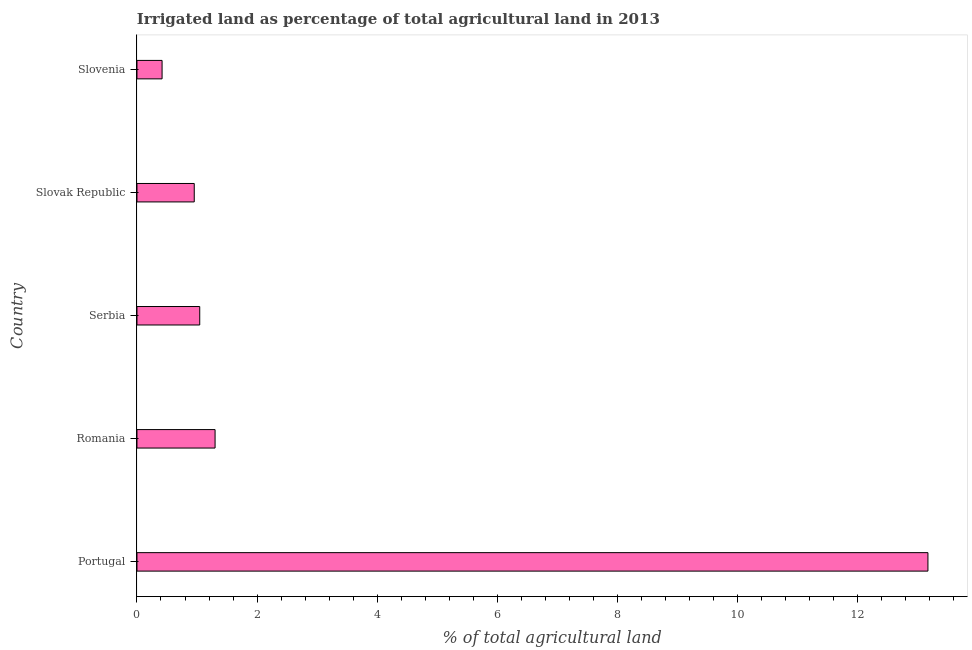Does the graph contain any zero values?
Offer a terse response. No. What is the title of the graph?
Make the answer very short. Irrigated land as percentage of total agricultural land in 2013. What is the label or title of the X-axis?
Ensure brevity in your answer.  % of total agricultural land. What is the percentage of agricultural irrigated land in Portugal?
Give a very brief answer. 13.17. Across all countries, what is the maximum percentage of agricultural irrigated land?
Keep it short and to the point. 13.17. Across all countries, what is the minimum percentage of agricultural irrigated land?
Provide a succinct answer. 0.42. In which country was the percentage of agricultural irrigated land minimum?
Your answer should be very brief. Slovenia. What is the sum of the percentage of agricultural irrigated land?
Provide a succinct answer. 16.89. What is the difference between the percentage of agricultural irrigated land in Serbia and Slovak Republic?
Provide a succinct answer. 0.09. What is the average percentage of agricultural irrigated land per country?
Your response must be concise. 3.38. What is the median percentage of agricultural irrigated land?
Provide a short and direct response. 1.05. In how many countries, is the percentage of agricultural irrigated land greater than 2.8 %?
Give a very brief answer. 1. What is the ratio of the percentage of agricultural irrigated land in Slovak Republic to that in Slovenia?
Your answer should be compact. 2.28. What is the difference between the highest and the second highest percentage of agricultural irrigated land?
Ensure brevity in your answer.  11.87. What is the difference between the highest and the lowest percentage of agricultural irrigated land?
Your response must be concise. 12.76. In how many countries, is the percentage of agricultural irrigated land greater than the average percentage of agricultural irrigated land taken over all countries?
Ensure brevity in your answer.  1. How many bars are there?
Make the answer very short. 5. Are all the bars in the graph horizontal?
Give a very brief answer. Yes. How many countries are there in the graph?
Your answer should be compact. 5. Are the values on the major ticks of X-axis written in scientific E-notation?
Offer a terse response. No. What is the % of total agricultural land in Portugal?
Your answer should be compact. 13.17. What is the % of total agricultural land of Romania?
Your answer should be very brief. 1.3. What is the % of total agricultural land in Serbia?
Your answer should be very brief. 1.05. What is the % of total agricultural land of Slovak Republic?
Make the answer very short. 0.95. What is the % of total agricultural land in Slovenia?
Ensure brevity in your answer.  0.42. What is the difference between the % of total agricultural land in Portugal and Romania?
Provide a short and direct response. 11.87. What is the difference between the % of total agricultural land in Portugal and Serbia?
Offer a very short reply. 12.13. What is the difference between the % of total agricultural land in Portugal and Slovak Republic?
Provide a short and direct response. 12.22. What is the difference between the % of total agricultural land in Portugal and Slovenia?
Offer a terse response. 12.76. What is the difference between the % of total agricultural land in Romania and Serbia?
Offer a terse response. 0.26. What is the difference between the % of total agricultural land in Romania and Slovak Republic?
Your answer should be compact. 0.35. What is the difference between the % of total agricultural land in Romania and Slovenia?
Provide a succinct answer. 0.88. What is the difference between the % of total agricultural land in Serbia and Slovak Republic?
Your answer should be compact. 0.09. What is the difference between the % of total agricultural land in Serbia and Slovenia?
Provide a short and direct response. 0.63. What is the difference between the % of total agricultural land in Slovak Republic and Slovenia?
Provide a succinct answer. 0.54. What is the ratio of the % of total agricultural land in Portugal to that in Romania?
Offer a very short reply. 10.13. What is the ratio of the % of total agricultural land in Portugal to that in Slovak Republic?
Give a very brief answer. 13.81. What is the ratio of the % of total agricultural land in Portugal to that in Slovenia?
Provide a short and direct response. 31.49. What is the ratio of the % of total agricultural land in Romania to that in Serbia?
Ensure brevity in your answer.  1.24. What is the ratio of the % of total agricultural land in Romania to that in Slovak Republic?
Ensure brevity in your answer.  1.36. What is the ratio of the % of total agricultural land in Romania to that in Slovenia?
Offer a terse response. 3.11. What is the ratio of the % of total agricultural land in Serbia to that in Slovak Republic?
Your response must be concise. 1.1. What is the ratio of the % of total agricultural land in Serbia to that in Slovenia?
Your answer should be compact. 2.5. What is the ratio of the % of total agricultural land in Slovak Republic to that in Slovenia?
Ensure brevity in your answer.  2.28. 